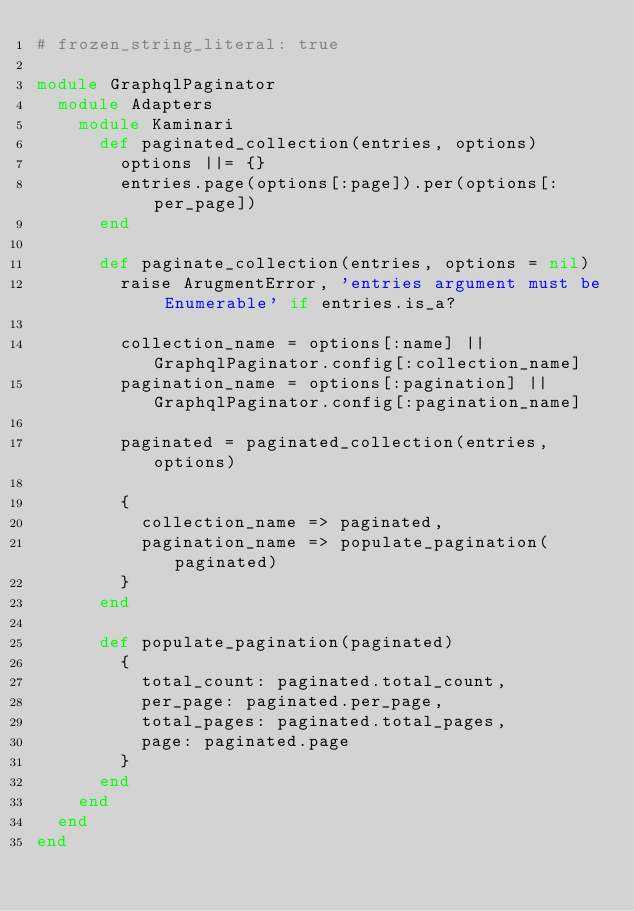Convert code to text. <code><loc_0><loc_0><loc_500><loc_500><_Ruby_># frozen_string_literal: true

module GraphqlPaginator
  module Adapters
    module Kaminari
      def paginated_collection(entries, options)
        options ||= {}
        entries.page(options[:page]).per(options[:per_page])
      end

      def paginate_collection(entries, options = nil)
        raise ArugmentError, 'entries argument must be Enumerable' if entries.is_a?

        collection_name = options[:name] || GraphqlPaginator.config[:collection_name]
        pagination_name = options[:pagination] || GraphqlPaginator.config[:pagination_name]

        paginated = paginated_collection(entries, options)

        {
          collection_name => paginated,
          pagination_name => populate_pagination(paginated)
        }
      end

      def populate_pagination(paginated)
        {
          total_count: paginated.total_count,
          per_page: paginated.per_page,
          total_pages: paginated.total_pages,
          page: paginated.page
        }
      end
    end
  end
end
</code> 